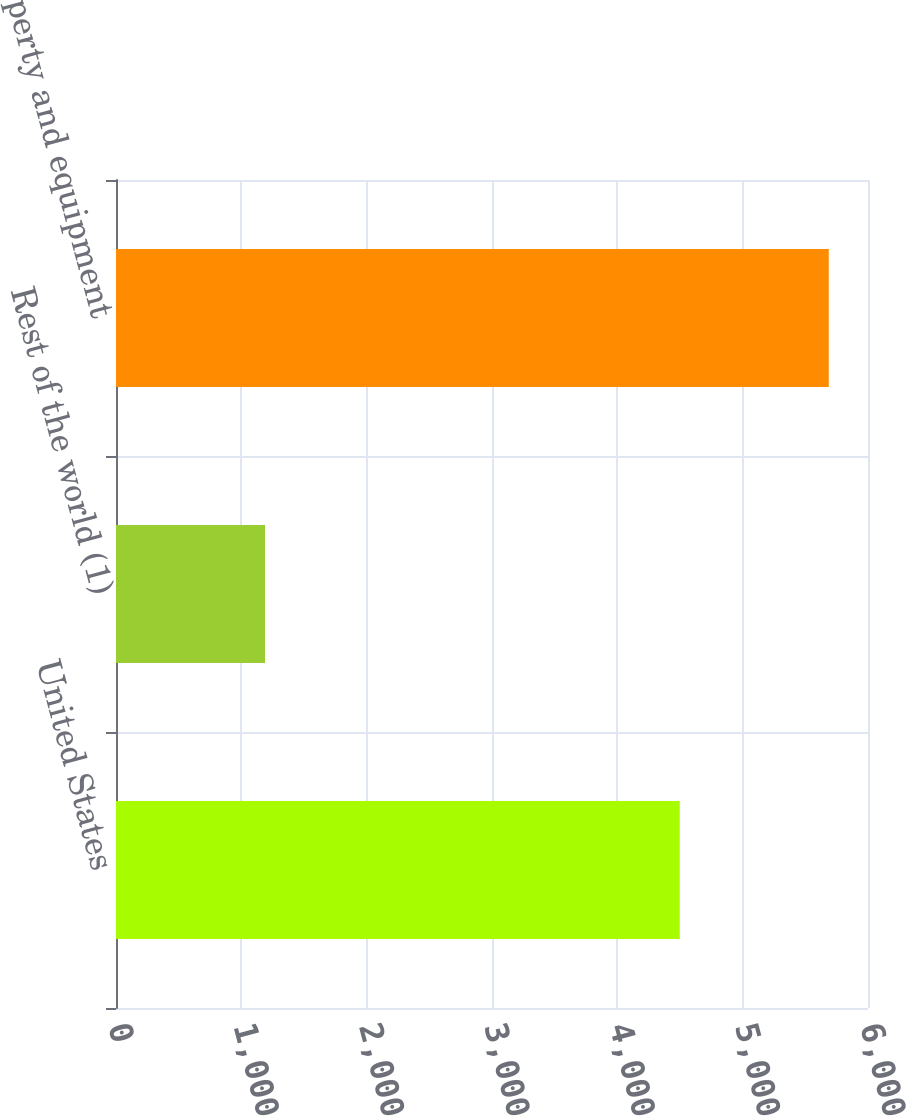Convert chart. <chart><loc_0><loc_0><loc_500><loc_500><bar_chart><fcel>United States<fcel>Rest of the world (1)<fcel>Total property and equipment<nl><fcel>4498<fcel>1189<fcel>5687<nl></chart> 